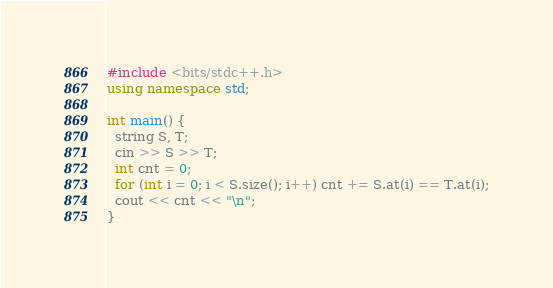Convert code to text. <code><loc_0><loc_0><loc_500><loc_500><_C++_>#include <bits/stdc++.h>
using namespace std;

int main() {
  string S, T;
  cin >> S >> T;
  int cnt = 0;
  for (int i = 0; i < S.size(); i++) cnt += S.at(i) == T.at(i);
  cout << cnt << "\n";
}</code> 